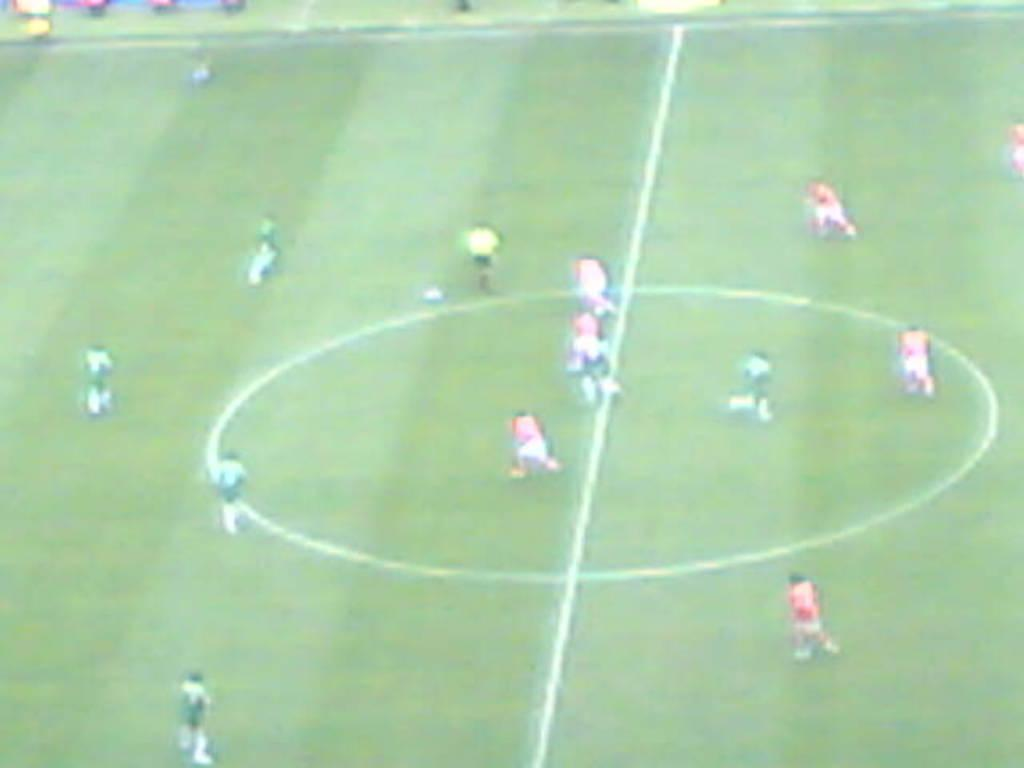Where was the image taken? The image was taken in a stadium. What activity is happening in the stadium? People are playing in the stadium. What type of silverware is being used by the players in the image? There is no silverware present in the image, as the people are playing in a stadium, which typically involves sports or other physical activities. 